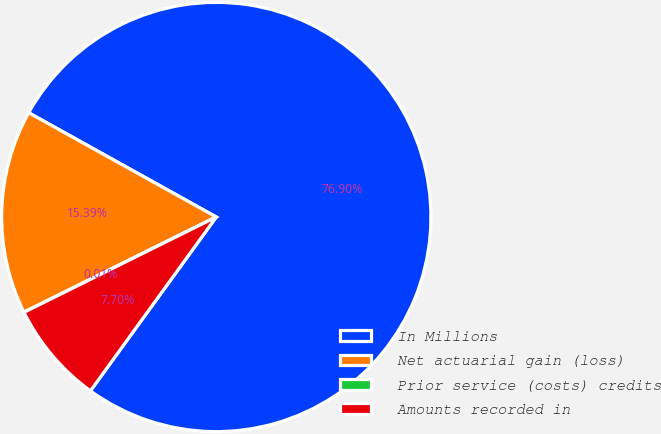Convert chart to OTSL. <chart><loc_0><loc_0><loc_500><loc_500><pie_chart><fcel>In Millions<fcel>Net actuarial gain (loss)<fcel>Prior service (costs) credits<fcel>Amounts recorded in<nl><fcel>76.9%<fcel>15.39%<fcel>0.01%<fcel>7.7%<nl></chart> 